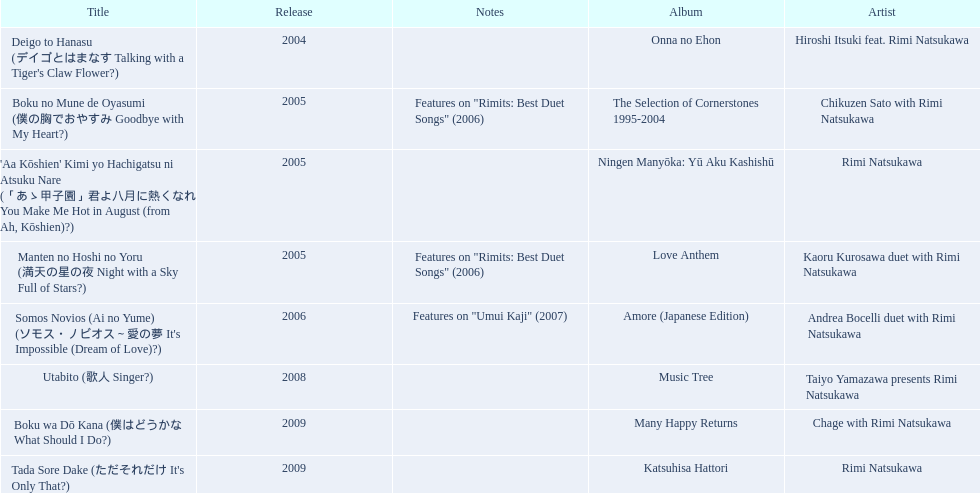What are the names of each album by rimi natsukawa? Onna no Ehon, The Selection of Cornerstones 1995-2004, Ningen Manyōka: Yū Aku Kashishū, Love Anthem, Amore (Japanese Edition), Music Tree, Many Happy Returns, Katsuhisa Hattori. And when were the albums released? 2004, 2005, 2005, 2005, 2006, 2008, 2009, 2009. Was onna no ehon or music tree released most recently? Music Tree. 